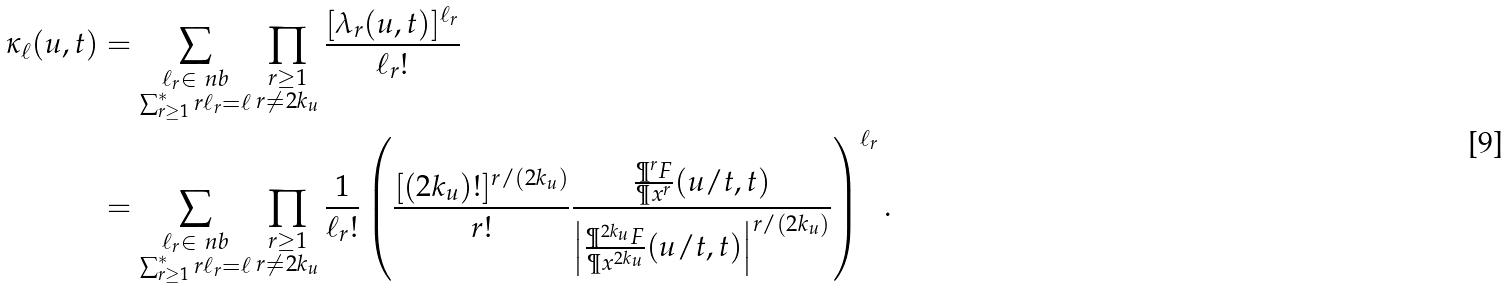<formula> <loc_0><loc_0><loc_500><loc_500>\kappa _ { \ell } ( u , t ) & = \sum _ { \substack { \ell _ { r } \in \ n b \\ \sum _ { r \geq 1 } ^ { * } r \ell _ { r } = \ell } } \prod _ { \substack { r \geq 1 \\ r \neq 2 k _ { u } } } \frac { [ \lambda _ { r } ( u , t ) ] ^ { \ell _ { r } } } { \ell _ { r } ! } \\ & = \sum _ { \substack { \ell _ { r } \in \ n b \\ \sum _ { r \geq 1 } ^ { * } r \ell _ { r } = \ell } } \prod _ { \substack { r \geq 1 \\ r \neq 2 k _ { u } } } \frac { 1 } { \ell _ { r } ! } \left ( \frac { [ ( 2 k _ { u } ) ! ] ^ { r / ( 2 k _ { u } ) } } { r ! } \frac { \frac { \P ^ { r } F } { \P x ^ { r } } ( u / t , t ) } { \left | \frac { \P ^ { 2 k _ { u } } F } { \P x ^ { 2 k _ { u } } } ( u / t , t ) \right | ^ { r / ( 2 k _ { u } ) } } \right ) ^ { \ell _ { r } } .</formula> 